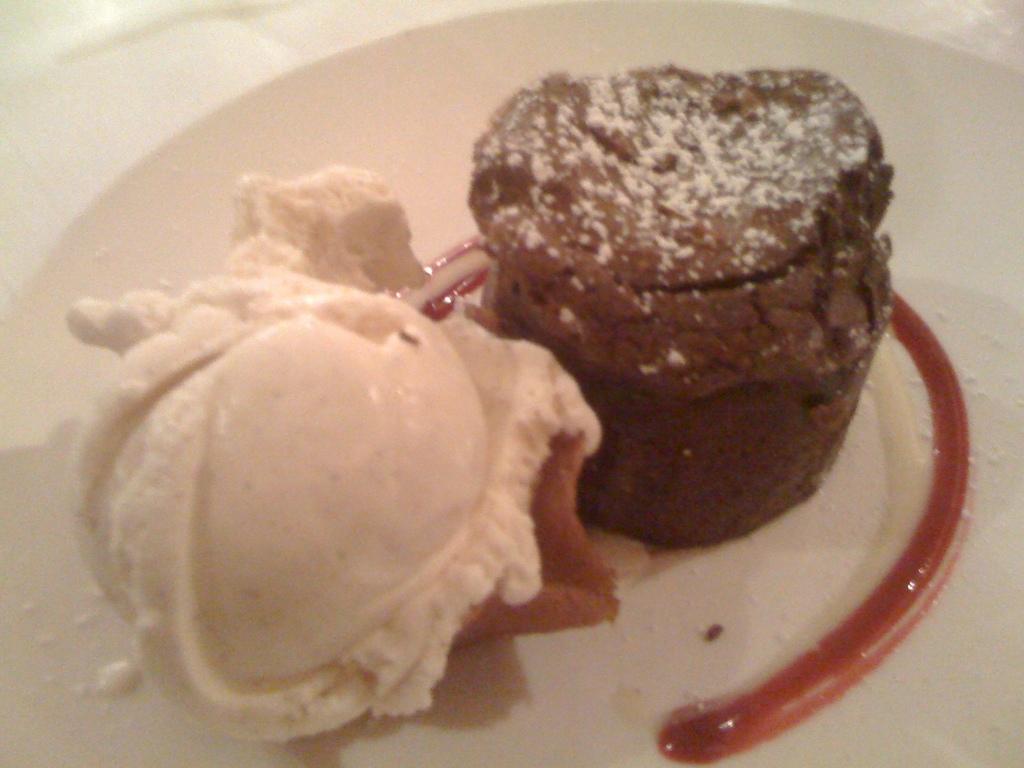Please provide a concise description of this image. In this image we can see the food item on the plate. 